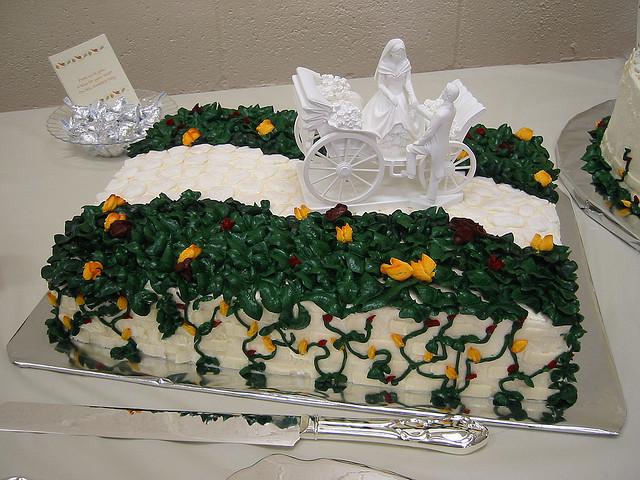Does the cake have corners?
Write a very short answer. Yes. Are those real flowers?
Answer briefly. No. What color is the frosting on the cake?
Keep it brief. Green and white. What scene is on the cake?
Short answer required. Marriage. What kind of cake is this?
Concise answer only. Wedding. What is in the dish on the left?
Answer briefly. Kisses. What event is being celebrated?
Give a very brief answer. Wedding. Where is the cake?
Keep it brief. Table. What color is the icing for the cake on the left?
Short answer required. Green. Is this a cake?
Short answer required. Yes. 